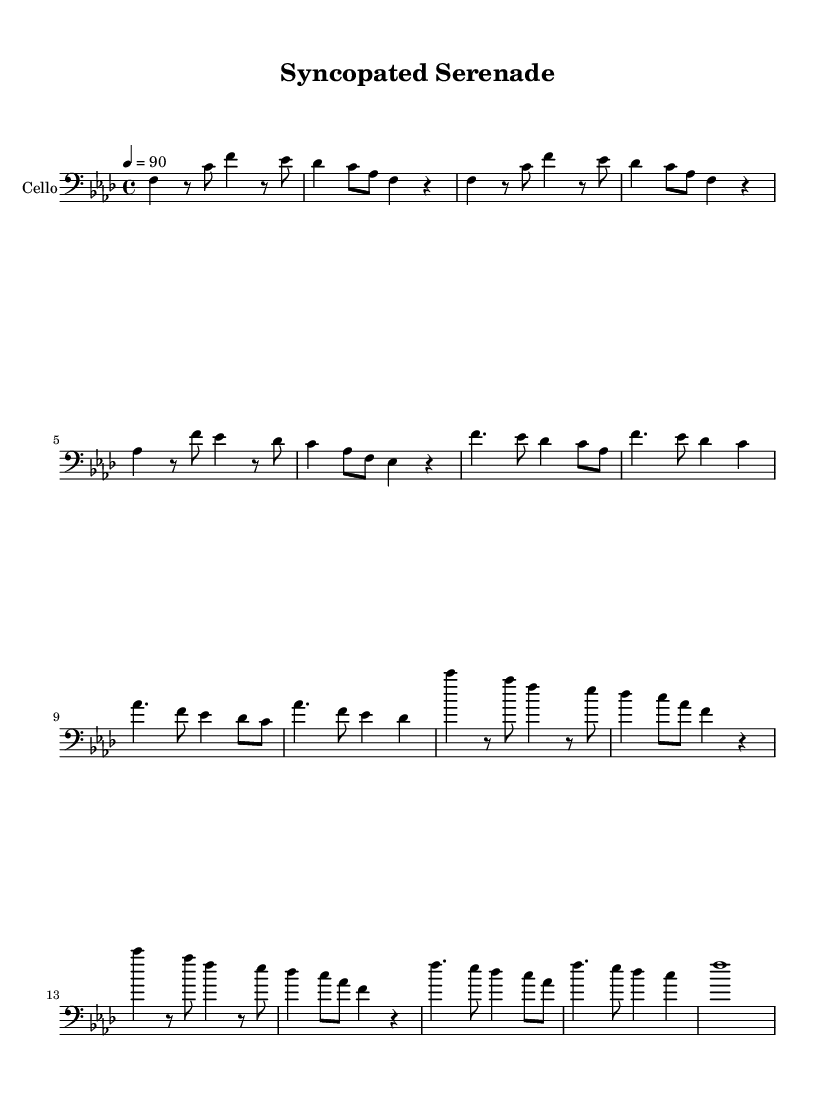What is the key signature of this music? The key signature is indicated by the key signature markings at the beginning of the staff, which shows four flats. These flats correspond to B flat, E flat, A flat, and D flat, which together define the key of F minor.
Answer: F minor What is the time signature of this music? The time signature is located at the beginning of the score, shown as a fraction. The notation '4/4' indicates that there are four beats in each measure and the quarter note gets one beat.
Answer: 4/4 What is the tempo marking for this piece? The tempo is given as '4 = 90' at the top of the score, meaning there are 90 beats per minute, and the quarter note is the beat.
Answer: 90 How many measures are there in the chorus section? By counting the measures within the chorus section (starting from the first measure labeled with the chorus material to the last), we see there are four measures in total.
Answer: 4 Which rhythmic pattern is most prominently featured in the verse? Looking at the verse section, the repetitive use of eighth notes followed by rests indicates a syncopated rhythm that is characteristic of contemporary R&B, emphasizing off-beat timing.
Answer: Syncopated rhythm What is unique about the phrasing in the bridge? The bridge section features a distinctive alternating pattern of quarter notes and eighth notes, creating a sense of tension and release, typical in Rhythm and Blues genres.
Answer: Alternative phrasing What is the relationship between the verses and the chorus? The verses mirror thematic ideas presented in the chorus, showcasing a call-and-response structure that is essential to Rhythm and Blues, enhancing emotional expression and connection to the lyrics.
Answer: Call-and-response structure 